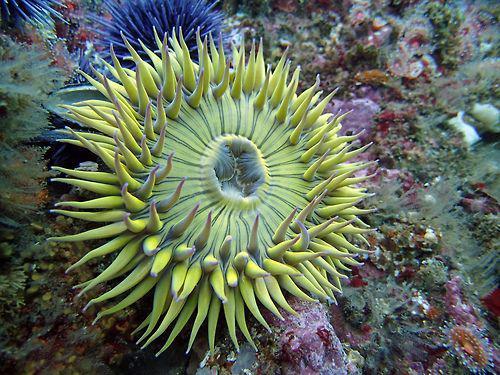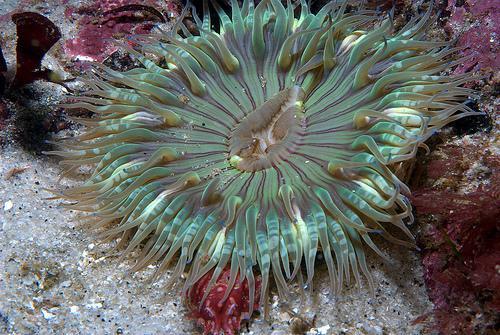The first image is the image on the left, the second image is the image on the right. For the images shown, is this caption "There is exactly one sea anemone in the right image." true? Answer yes or no. Yes. The first image is the image on the left, the second image is the image on the right. For the images shown, is this caption "Each image shows one prominent flower-shaped anemone with tendrils radiating from a flatter center with a hole in it, but the anemone on the right is greenish-blue, and the one on the left is more yellowish." true? Answer yes or no. Yes. 